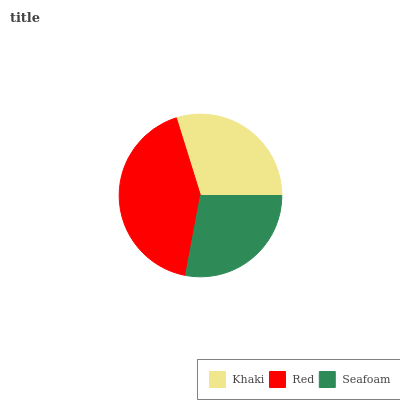Is Seafoam the minimum?
Answer yes or no. Yes. Is Red the maximum?
Answer yes or no. Yes. Is Red the minimum?
Answer yes or no. No. Is Seafoam the maximum?
Answer yes or no. No. Is Red greater than Seafoam?
Answer yes or no. Yes. Is Seafoam less than Red?
Answer yes or no. Yes. Is Seafoam greater than Red?
Answer yes or no. No. Is Red less than Seafoam?
Answer yes or no. No. Is Khaki the high median?
Answer yes or no. Yes. Is Khaki the low median?
Answer yes or no. Yes. Is Red the high median?
Answer yes or no. No. Is Seafoam the low median?
Answer yes or no. No. 